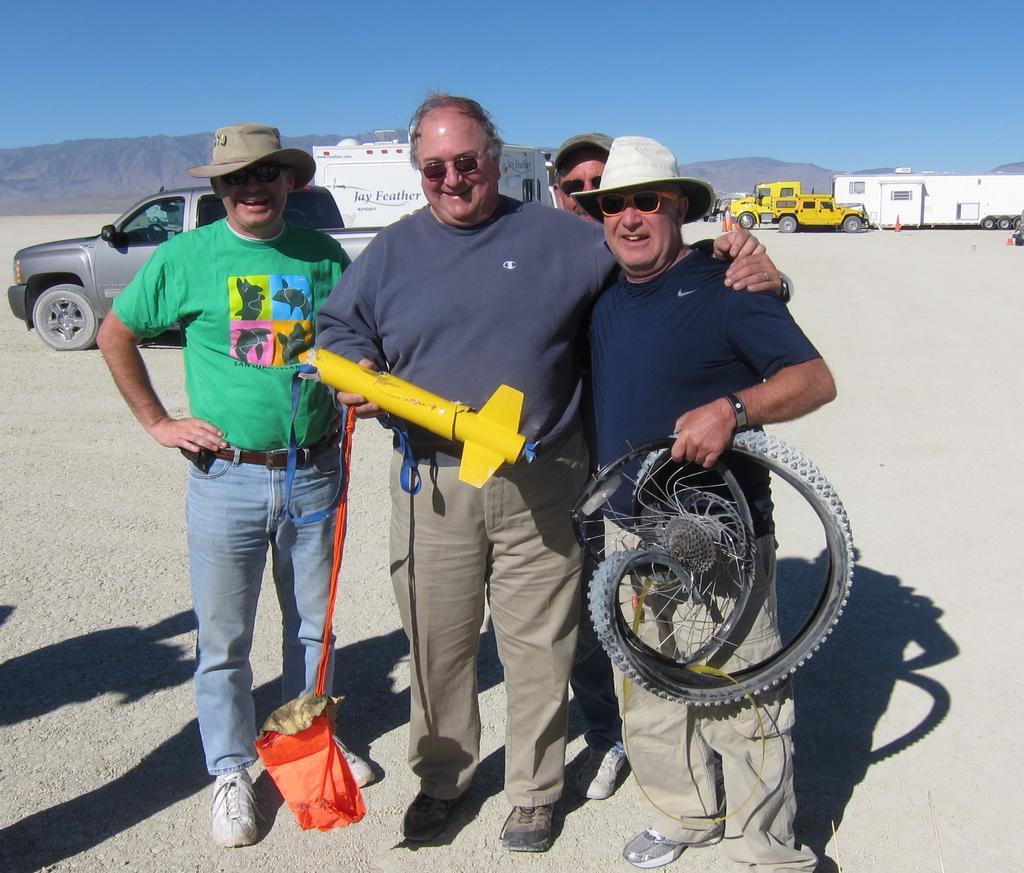Describe this image in one or two sentences. In this image, we can see four people are standing on the ground. Few are holding some objects. Background we can see few vehicles, mountains. Top of the image, there is a clear sky. Here we can see these people are smiling. 